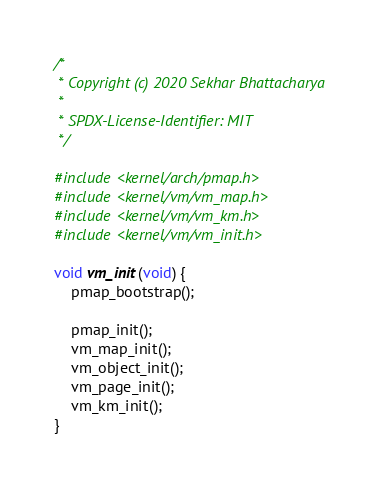<code> <loc_0><loc_0><loc_500><loc_500><_C_>/*
 * Copyright (c) 2020 Sekhar Bhattacharya
 *
 * SPDX-License-Identifier: MIT
 */

#include <kernel/arch/pmap.h>
#include <kernel/vm/vm_map.h>
#include <kernel/vm/vm_km.h>
#include <kernel/vm/vm_init.h>

void vm_init(void) {
    pmap_bootstrap();

    pmap_init();
    vm_map_init();
    vm_object_init();
    vm_page_init();
    vm_km_init();
}
</code> 